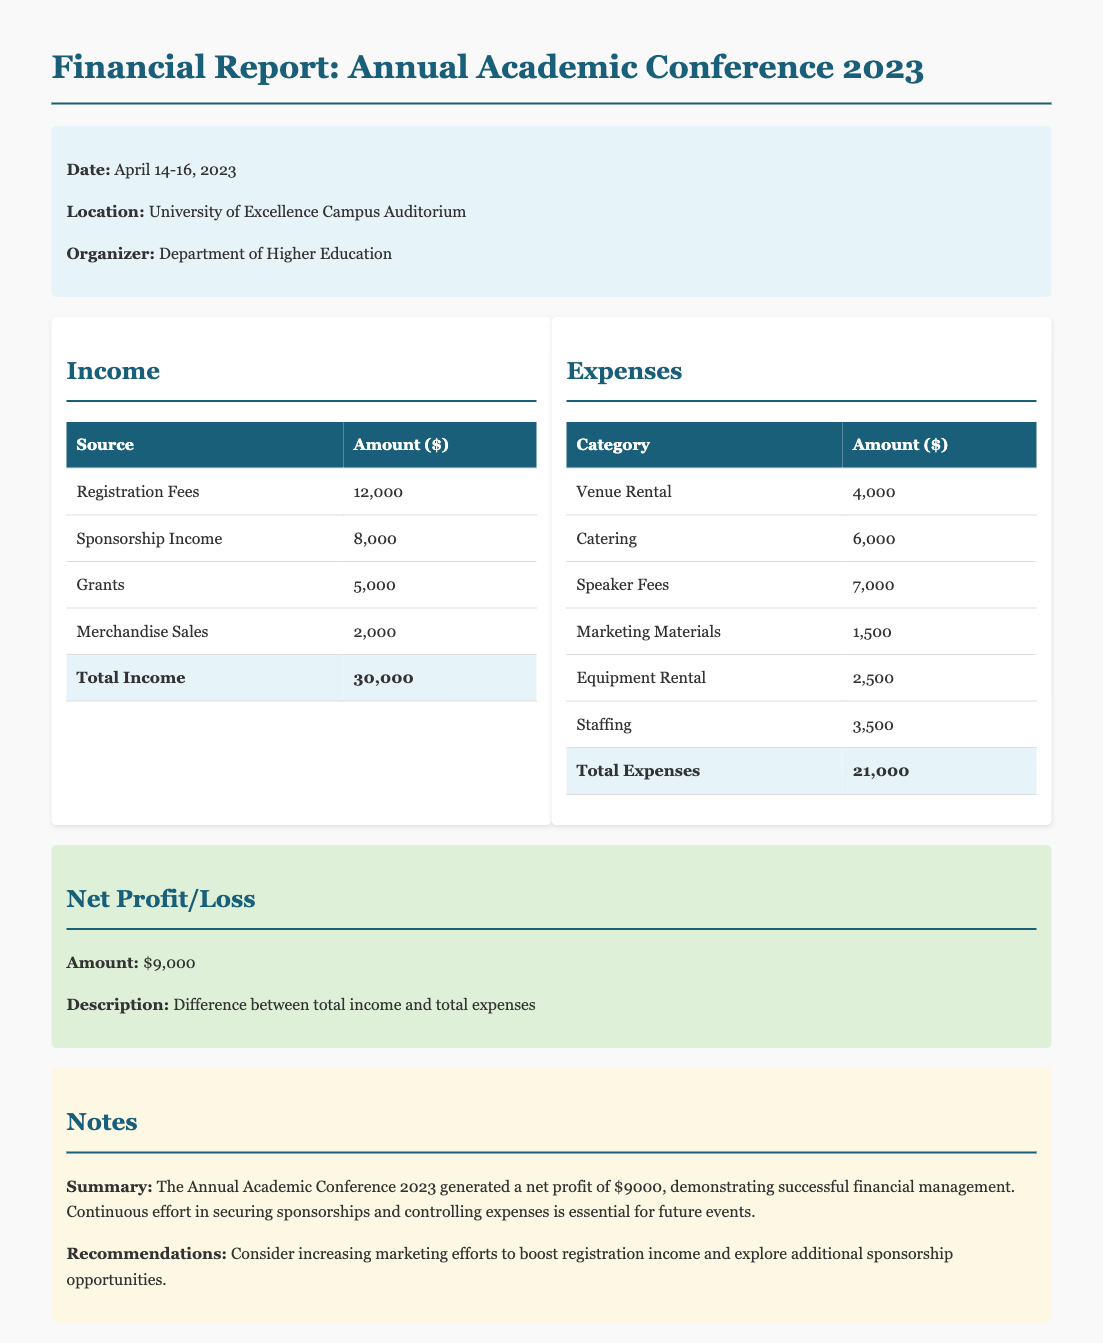What is the date of the conference? The date of the conference is specified in the document, which is April 14-16, 2023.
Answer: April 14-16, 2023 What is the total income from registration fees? The amount from registration fees is listed in the income table as $12,000.
Answer: $12,000 How much were the total expenses? The total expenses are explicitly stated in the document as $21,000, coming from the sum of all expense categories.
Answer: $21,000 What is the net profit generated from the conference? The net profit is calculated by subtracting total expenses from total income, resulting in a net profit of $9,000.
Answer: $9,000 What is the location of the conference? The location of the conference is clearly mentioned as the University of Excellence Campus Auditorium.
Answer: University of Excellence Campus Auditorium What percentage of total income comes from sponsorship income? The sponsorship income is $8,000, which is a part of the total income of $30,000. Calculating the percentage gives us approximately 26.67%.
Answer: 26.67% What were the speaker fees for the conference? The speaker fees are listed in the expenses table as $7,000.
Answer: $7,000 What recommendations are given for future events? The recommendations in the notes section suggest increasing marketing efforts and exploring additional sponsorship opportunities.
Answer: Increasing marketing efforts and exploring additional sponsorship opportunities 